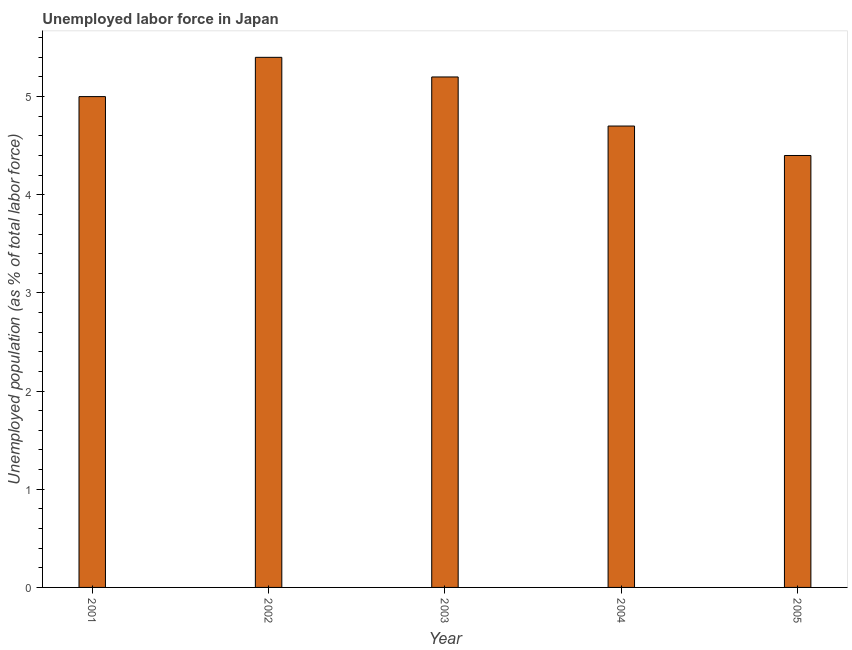What is the title of the graph?
Your response must be concise. Unemployed labor force in Japan. What is the label or title of the X-axis?
Offer a terse response. Year. What is the label or title of the Y-axis?
Offer a very short reply. Unemployed population (as % of total labor force). What is the total unemployed population in 2004?
Your answer should be compact. 4.7. Across all years, what is the maximum total unemployed population?
Provide a succinct answer. 5.4. Across all years, what is the minimum total unemployed population?
Give a very brief answer. 4.4. In which year was the total unemployed population minimum?
Give a very brief answer. 2005. What is the sum of the total unemployed population?
Give a very brief answer. 24.7. What is the average total unemployed population per year?
Offer a very short reply. 4.94. What is the median total unemployed population?
Offer a very short reply. 5. In how many years, is the total unemployed population greater than 2.2 %?
Keep it short and to the point. 5. What is the ratio of the total unemployed population in 2001 to that in 2004?
Offer a very short reply. 1.06. Is the total unemployed population in 2001 less than that in 2003?
Provide a short and direct response. Yes. Is the difference between the total unemployed population in 2003 and 2004 greater than the difference between any two years?
Provide a short and direct response. No. What is the difference between the highest and the second highest total unemployed population?
Keep it short and to the point. 0.2. Is the sum of the total unemployed population in 2001 and 2005 greater than the maximum total unemployed population across all years?
Provide a short and direct response. Yes. What is the difference between the highest and the lowest total unemployed population?
Your response must be concise. 1. What is the difference between two consecutive major ticks on the Y-axis?
Provide a succinct answer. 1. What is the Unemployed population (as % of total labor force) of 2001?
Provide a short and direct response. 5. What is the Unemployed population (as % of total labor force) of 2002?
Your response must be concise. 5.4. What is the Unemployed population (as % of total labor force) in 2003?
Your answer should be very brief. 5.2. What is the Unemployed population (as % of total labor force) in 2004?
Provide a short and direct response. 4.7. What is the Unemployed population (as % of total labor force) in 2005?
Your response must be concise. 4.4. What is the difference between the Unemployed population (as % of total labor force) in 2001 and 2003?
Make the answer very short. -0.2. What is the difference between the Unemployed population (as % of total labor force) in 2002 and 2003?
Make the answer very short. 0.2. What is the difference between the Unemployed population (as % of total labor force) in 2003 and 2004?
Give a very brief answer. 0.5. What is the difference between the Unemployed population (as % of total labor force) in 2003 and 2005?
Ensure brevity in your answer.  0.8. What is the difference between the Unemployed population (as % of total labor force) in 2004 and 2005?
Offer a very short reply. 0.3. What is the ratio of the Unemployed population (as % of total labor force) in 2001 to that in 2002?
Your answer should be very brief. 0.93. What is the ratio of the Unemployed population (as % of total labor force) in 2001 to that in 2003?
Make the answer very short. 0.96. What is the ratio of the Unemployed population (as % of total labor force) in 2001 to that in 2004?
Ensure brevity in your answer.  1.06. What is the ratio of the Unemployed population (as % of total labor force) in 2001 to that in 2005?
Your answer should be compact. 1.14. What is the ratio of the Unemployed population (as % of total labor force) in 2002 to that in 2003?
Your answer should be compact. 1.04. What is the ratio of the Unemployed population (as % of total labor force) in 2002 to that in 2004?
Give a very brief answer. 1.15. What is the ratio of the Unemployed population (as % of total labor force) in 2002 to that in 2005?
Your response must be concise. 1.23. What is the ratio of the Unemployed population (as % of total labor force) in 2003 to that in 2004?
Make the answer very short. 1.11. What is the ratio of the Unemployed population (as % of total labor force) in 2003 to that in 2005?
Your answer should be very brief. 1.18. What is the ratio of the Unemployed population (as % of total labor force) in 2004 to that in 2005?
Your answer should be very brief. 1.07. 